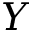Convert formula to latex. <formula><loc_0><loc_0><loc_500><loc_500>Y</formula> 